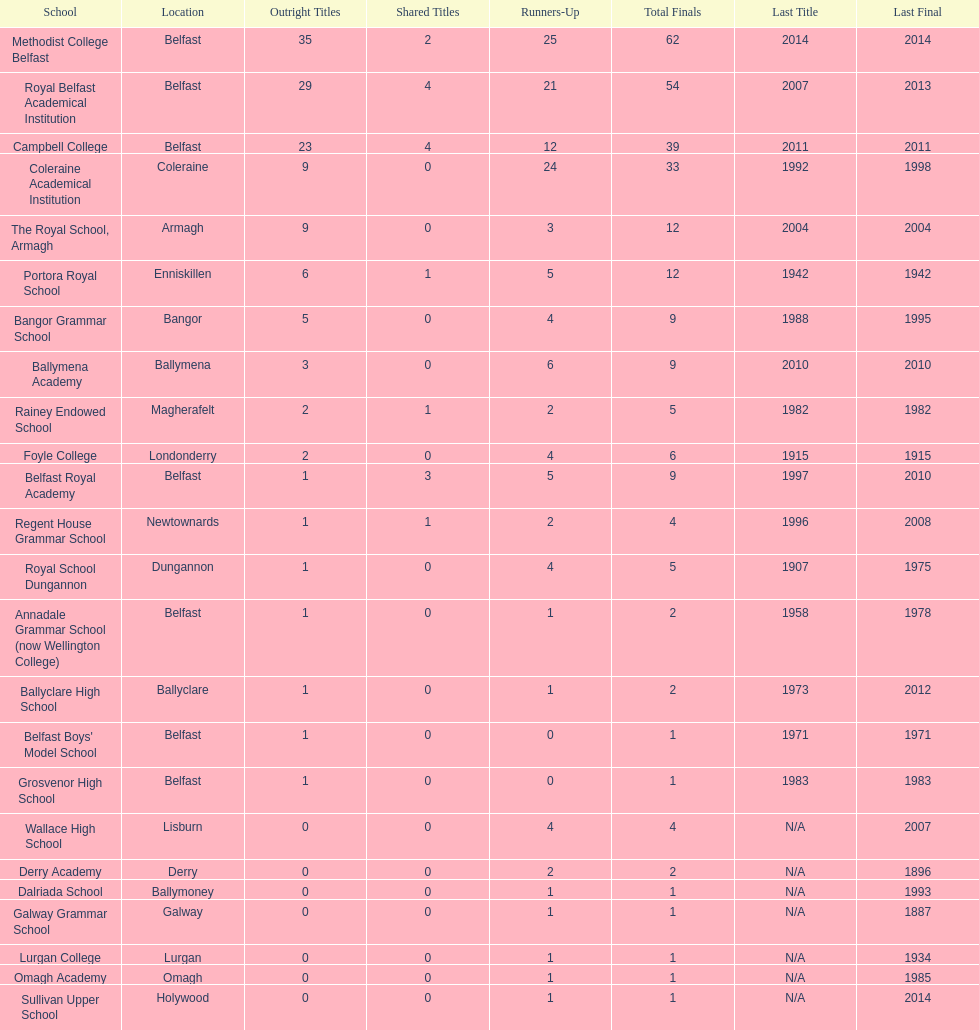Did belfast royal academy have more or less total finals than ballyclare high school? More. 